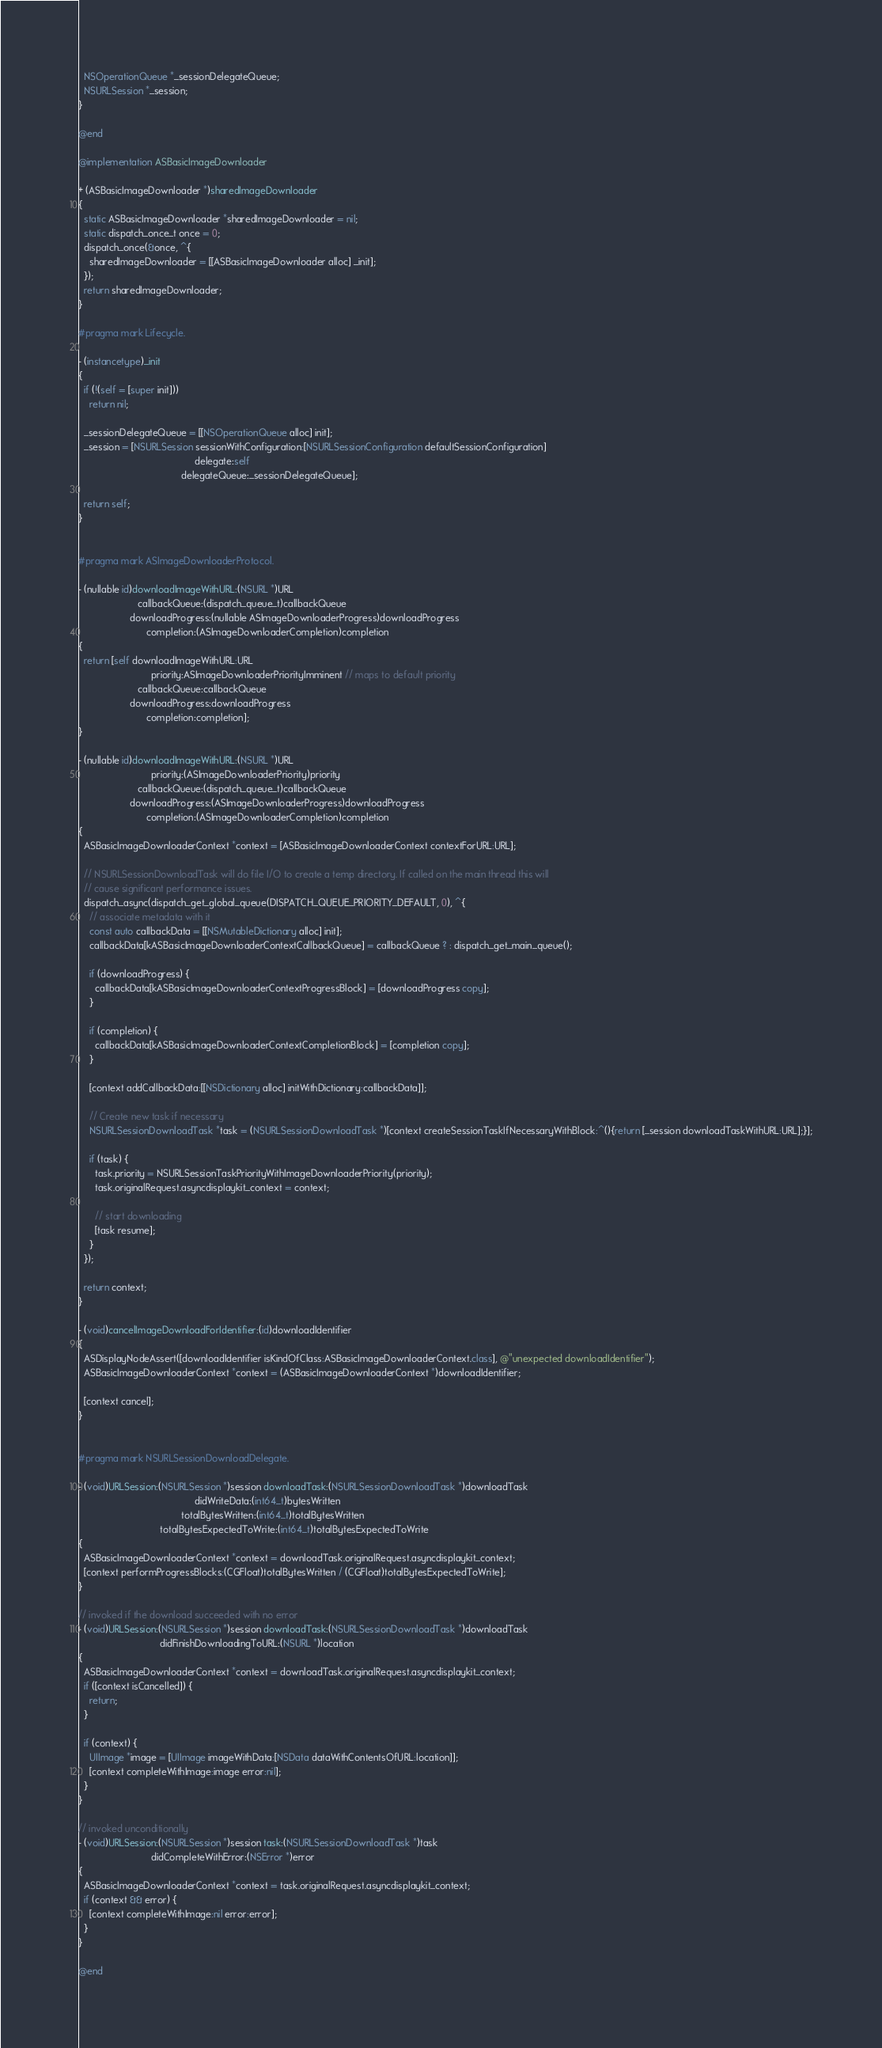<code> <loc_0><loc_0><loc_500><loc_500><_ObjectiveC_>  NSOperationQueue *_sessionDelegateQueue;
  NSURLSession *_session;
}

@end

@implementation ASBasicImageDownloader

+ (ASBasicImageDownloader *)sharedImageDownloader
{
  static ASBasicImageDownloader *sharedImageDownloader = nil;
  static dispatch_once_t once = 0;
  dispatch_once(&once, ^{
    sharedImageDownloader = [[ASBasicImageDownloader alloc] _init];
  });
  return sharedImageDownloader;
}

#pragma mark Lifecycle.

- (instancetype)_init
{
  if (!(self = [super init]))
    return nil;

  _sessionDelegateQueue = [[NSOperationQueue alloc] init];
  _session = [NSURLSession sessionWithConfiguration:[NSURLSessionConfiguration defaultSessionConfiguration]
                                           delegate:self
                                      delegateQueue:_sessionDelegateQueue];

  return self;
}


#pragma mark ASImageDownloaderProtocol.

- (nullable id)downloadImageWithURL:(NSURL *)URL
                      callbackQueue:(dispatch_queue_t)callbackQueue
                   downloadProgress:(nullable ASImageDownloaderProgress)downloadProgress
                         completion:(ASImageDownloaderCompletion)completion
{
  return [self downloadImageWithURL:URL
                           priority:ASImageDownloaderPriorityImminent // maps to default priority
                      callbackQueue:callbackQueue
                   downloadProgress:downloadProgress
                         completion:completion];
}

- (nullable id)downloadImageWithURL:(NSURL *)URL
                           priority:(ASImageDownloaderPriority)priority
                      callbackQueue:(dispatch_queue_t)callbackQueue
                   downloadProgress:(ASImageDownloaderProgress)downloadProgress
                         completion:(ASImageDownloaderCompletion)completion
{
  ASBasicImageDownloaderContext *context = [ASBasicImageDownloaderContext contextForURL:URL];

  // NSURLSessionDownloadTask will do file I/O to create a temp directory. If called on the main thread this will
  // cause significant performance issues.
  dispatch_async(dispatch_get_global_queue(DISPATCH_QUEUE_PRIORITY_DEFAULT, 0), ^{
    // associate metadata with it
    const auto callbackData = [[NSMutableDictionary alloc] init];
    callbackData[kASBasicImageDownloaderContextCallbackQueue] = callbackQueue ? : dispatch_get_main_queue();

    if (downloadProgress) {
      callbackData[kASBasicImageDownloaderContextProgressBlock] = [downloadProgress copy];
    }

    if (completion) {
      callbackData[kASBasicImageDownloaderContextCompletionBlock] = [completion copy];
    }

    [context addCallbackData:[[NSDictionary alloc] initWithDictionary:callbackData]];

    // Create new task if necessary
    NSURLSessionDownloadTask *task = (NSURLSessionDownloadTask *)[context createSessionTaskIfNecessaryWithBlock:^(){return [_session downloadTaskWithURL:URL];}];

    if (task) {
      task.priority = NSURLSessionTaskPriorityWithImageDownloaderPriority(priority);
      task.originalRequest.asyncdisplaykit_context = context;

      // start downloading
      [task resume];
    }
  });

  return context;
}

- (void)cancelImageDownloadForIdentifier:(id)downloadIdentifier
{
  ASDisplayNodeAssert([downloadIdentifier isKindOfClass:ASBasicImageDownloaderContext.class], @"unexpected downloadIdentifier");
  ASBasicImageDownloaderContext *context = (ASBasicImageDownloaderContext *)downloadIdentifier;

  [context cancel];
}


#pragma mark NSURLSessionDownloadDelegate.

- (void)URLSession:(NSURLSession *)session downloadTask:(NSURLSessionDownloadTask *)downloadTask
                                           didWriteData:(int64_t)bytesWritten
                                      totalBytesWritten:(int64_t)totalBytesWritten
                              totalBytesExpectedToWrite:(int64_t)totalBytesExpectedToWrite
{
  ASBasicImageDownloaderContext *context = downloadTask.originalRequest.asyncdisplaykit_context;
  [context performProgressBlocks:(CGFloat)totalBytesWritten / (CGFloat)totalBytesExpectedToWrite];
}

// invoked if the download succeeded with no error
- (void)URLSession:(NSURLSession *)session downloadTask:(NSURLSessionDownloadTask *)downloadTask
                              didFinishDownloadingToURL:(NSURL *)location
{
  ASBasicImageDownloaderContext *context = downloadTask.originalRequest.asyncdisplaykit_context;
  if ([context isCancelled]) {
    return;
  }

  if (context) {
    UIImage *image = [UIImage imageWithData:[NSData dataWithContentsOfURL:location]];
    [context completeWithImage:image error:nil];
  }
}

// invoked unconditionally
- (void)URLSession:(NSURLSession *)session task:(NSURLSessionDownloadTask *)task
                           didCompleteWithError:(NSError *)error
{
  ASBasicImageDownloaderContext *context = task.originalRequest.asyncdisplaykit_context;
  if (context && error) {
    [context completeWithImage:nil error:error];
  }
}

@end
</code> 